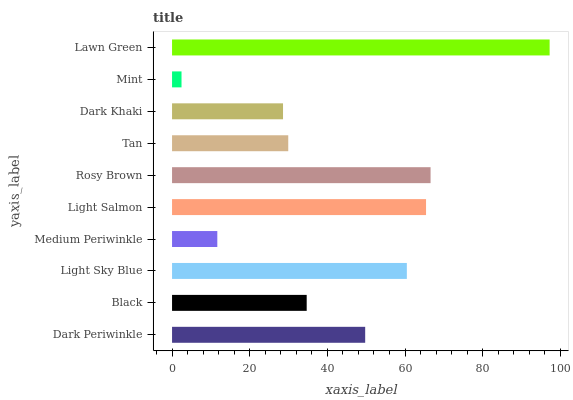Is Mint the minimum?
Answer yes or no. Yes. Is Lawn Green the maximum?
Answer yes or no. Yes. Is Black the minimum?
Answer yes or no. No. Is Black the maximum?
Answer yes or no. No. Is Dark Periwinkle greater than Black?
Answer yes or no. Yes. Is Black less than Dark Periwinkle?
Answer yes or no. Yes. Is Black greater than Dark Periwinkle?
Answer yes or no. No. Is Dark Periwinkle less than Black?
Answer yes or no. No. Is Dark Periwinkle the high median?
Answer yes or no. Yes. Is Black the low median?
Answer yes or no. Yes. Is Mint the high median?
Answer yes or no. No. Is Dark Khaki the low median?
Answer yes or no. No. 